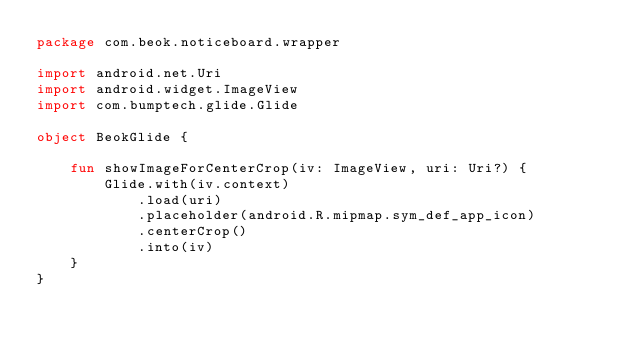Convert code to text. <code><loc_0><loc_0><loc_500><loc_500><_Kotlin_>package com.beok.noticeboard.wrapper

import android.net.Uri
import android.widget.ImageView
import com.bumptech.glide.Glide

object BeokGlide {

    fun showImageForCenterCrop(iv: ImageView, uri: Uri?) {
        Glide.with(iv.context)
            .load(uri)
            .placeholder(android.R.mipmap.sym_def_app_icon)
            .centerCrop()
            .into(iv)
    }
}</code> 